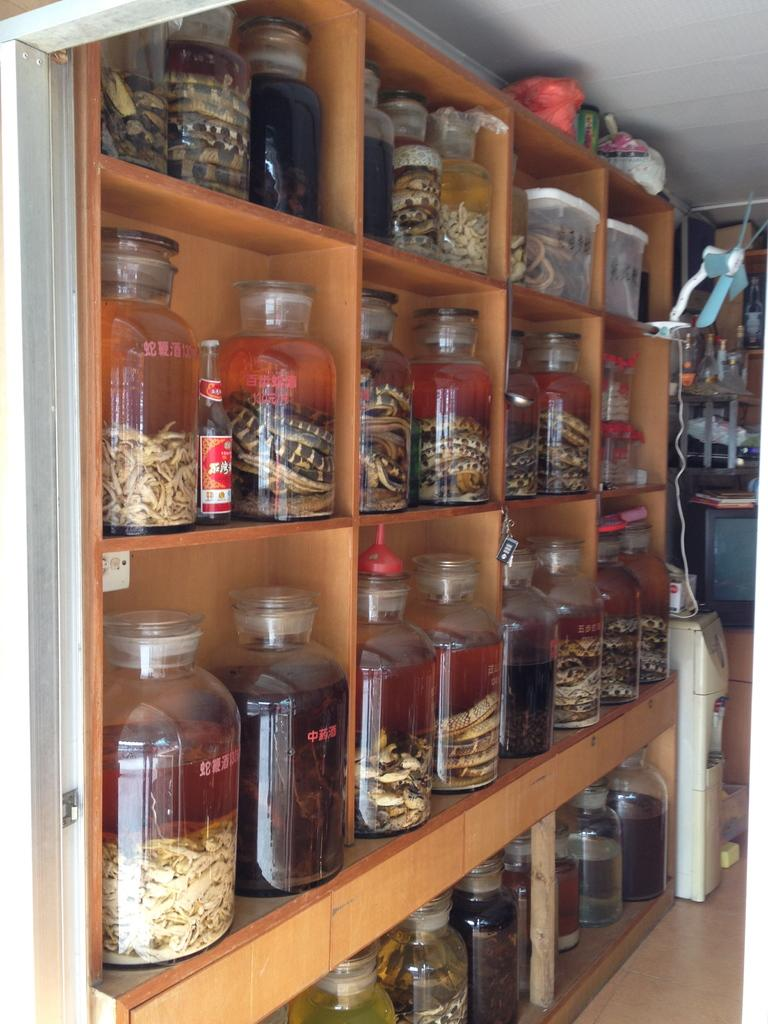What is the main object in the image? There is a rack in the image. What is stored on the rack? The rack contains containers. What are the containers filled with? The containers are full of something. What appliance is located on the right side of the image? There is a water purifier on the right side of the image. What is positioned above the water purifier? There is a fan placed above the water purifier. Can you see a hydrant in the image? There is no hydrant present in the image. What type of rice is being cooked in the containers on the rack? The contents of the containers are not specified, so it cannot be determined if rice is being cooked in them. 